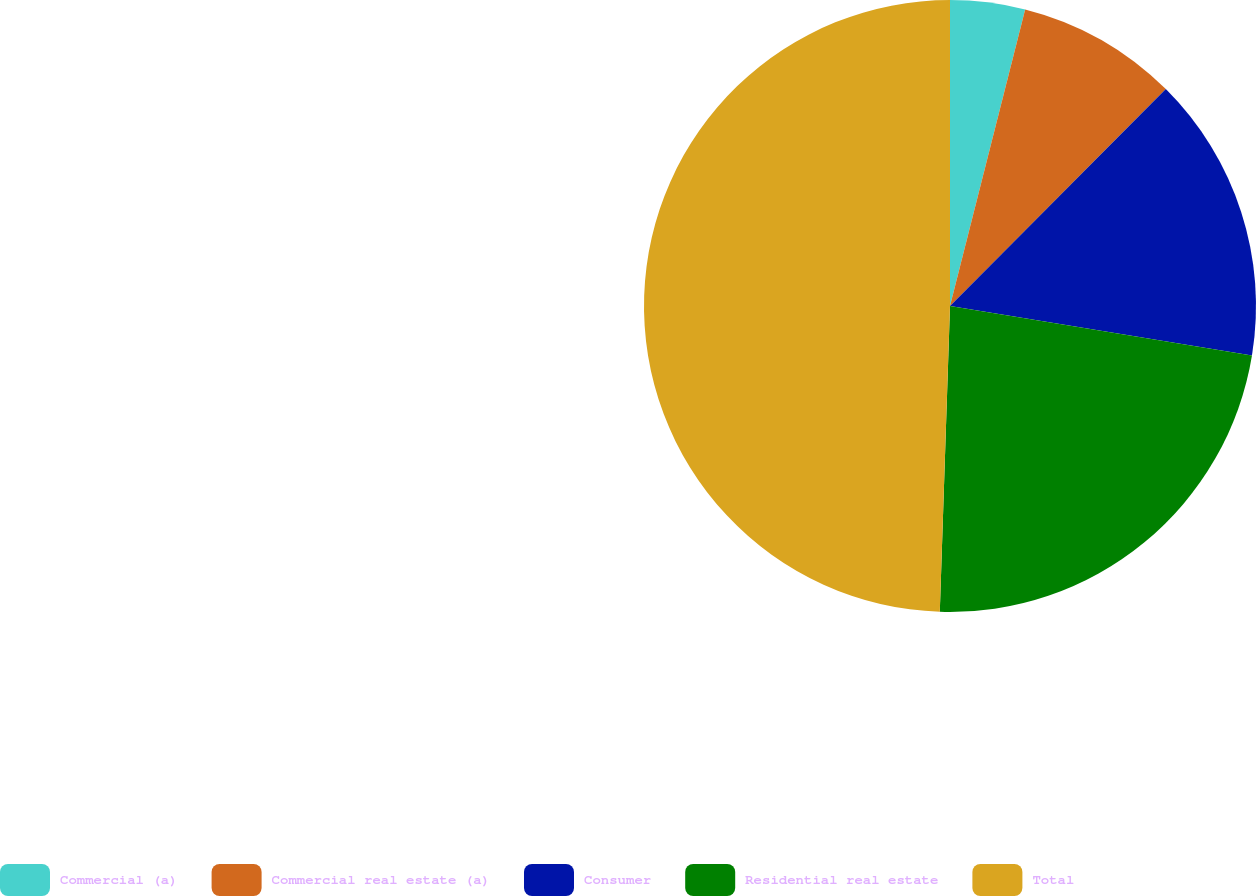<chart> <loc_0><loc_0><loc_500><loc_500><pie_chart><fcel>Commercial (a)<fcel>Commercial real estate (a)<fcel>Consumer<fcel>Residential real estate<fcel>Total<nl><fcel>3.95%<fcel>8.51%<fcel>15.13%<fcel>22.94%<fcel>49.47%<nl></chart> 